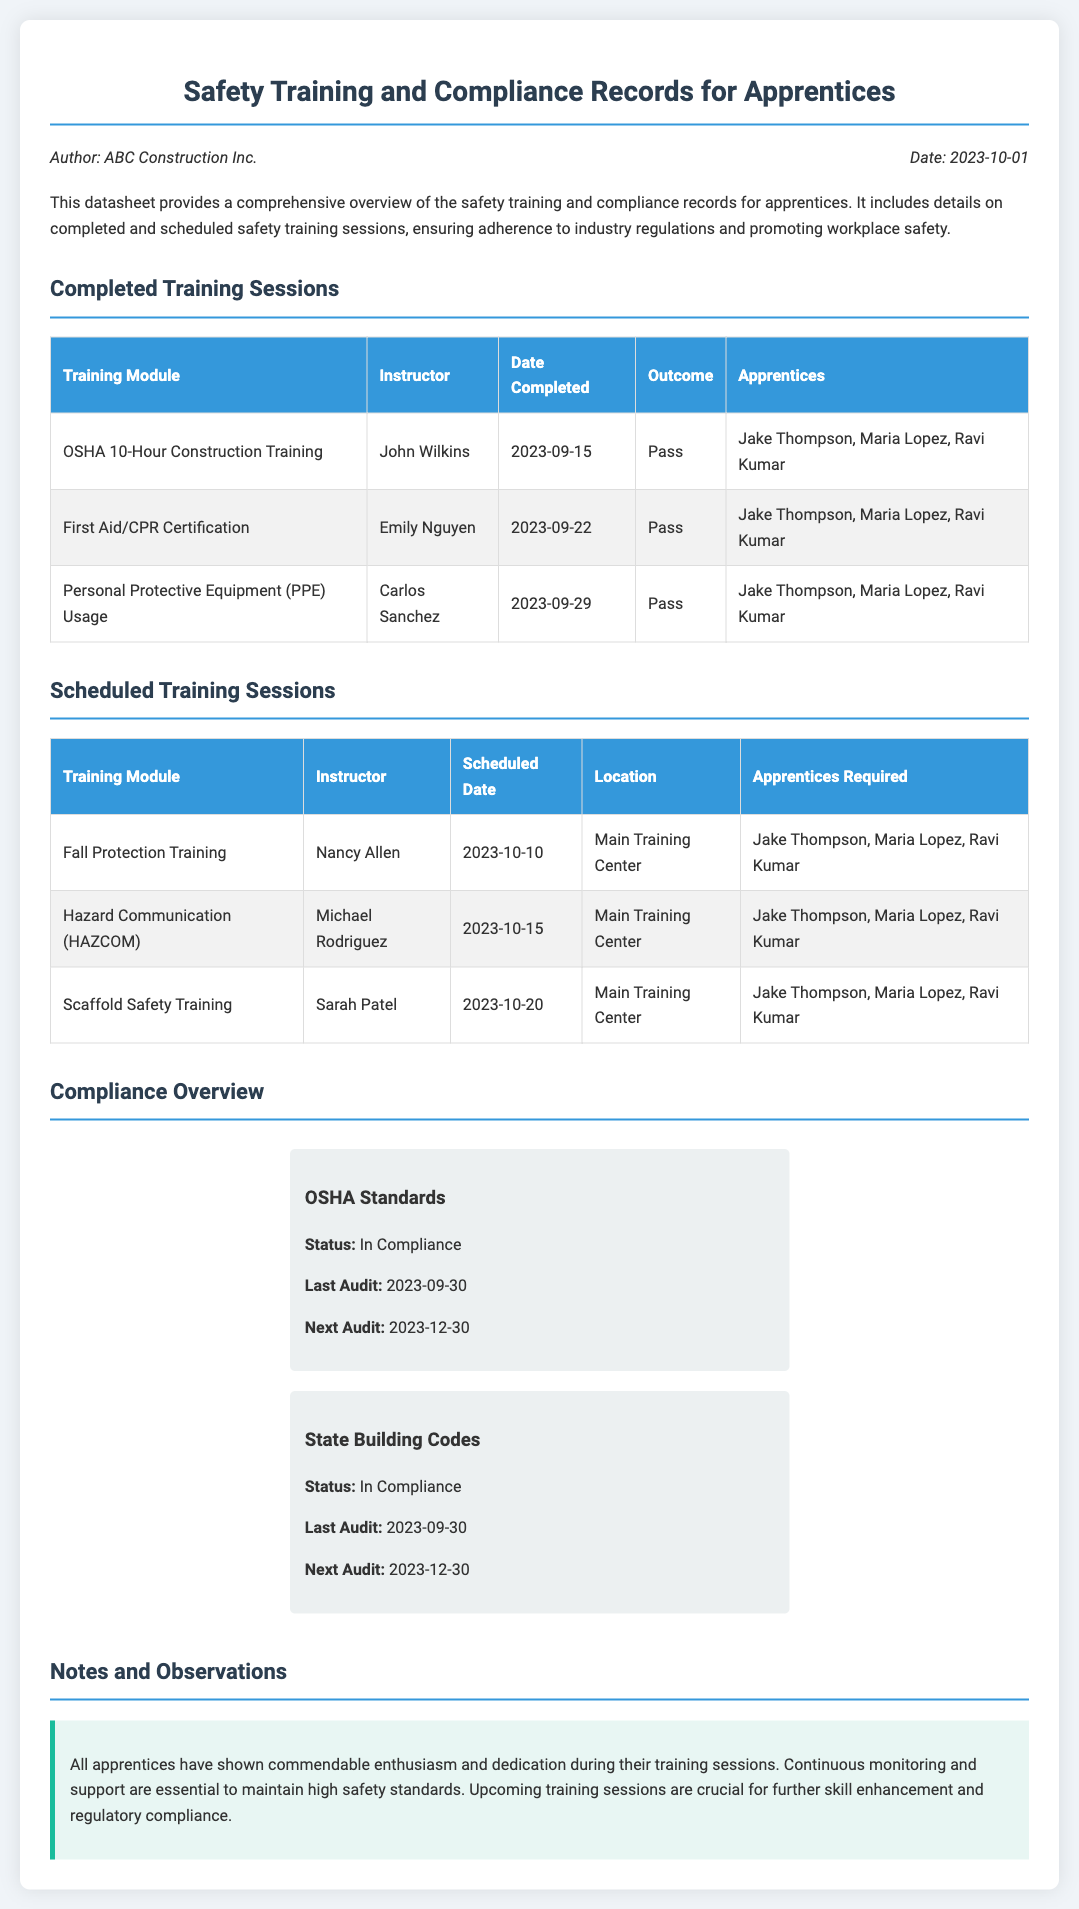what is the title of the datasheet? The title of the datasheet is provided as the main heading in the document.
Answer: Safety Training and Compliance Records for Apprentices who is the author of the datasheet? The author is mentioned in the information section at the beginning of the document.
Answer: ABC Construction Inc when was the last audit conducted? The last audit date is available in the compliance overview section for OSHA and State Building Codes.
Answer: 2023-09-30 which training module is scheduled for October 15, 2023? The scheduled date can be found in the table listing scheduled training sessions, along with the corresponding module.
Answer: Hazard Communication (HAZCOM) who is the instructor for the PPE usage training? The instructor's name is listed in the completed training sessions table corresponding to the PPE training module.
Answer: Carlos Sanchez what is the outcome of the First Aid/CPR Certification? The outcome can be found in the completed training sessions table under the relevant module.
Answer: Pass how many apprentices are required for the Fall Protection Training? The number of apprentices required is listed in the scheduled training sessions table for each session.
Answer: Jake Thompson, Maria Lopez, Ravi Kumar what is the status of OSHA Standards compliance? The status is indicated in the compliance overview section regarding OSHA Standards.
Answer: In Compliance what is highlighted in the notes and observations section? The content in this section summarizes the overall feelings towards the apprentices' training efforts.
Answer: Enthusiasm and dedication 